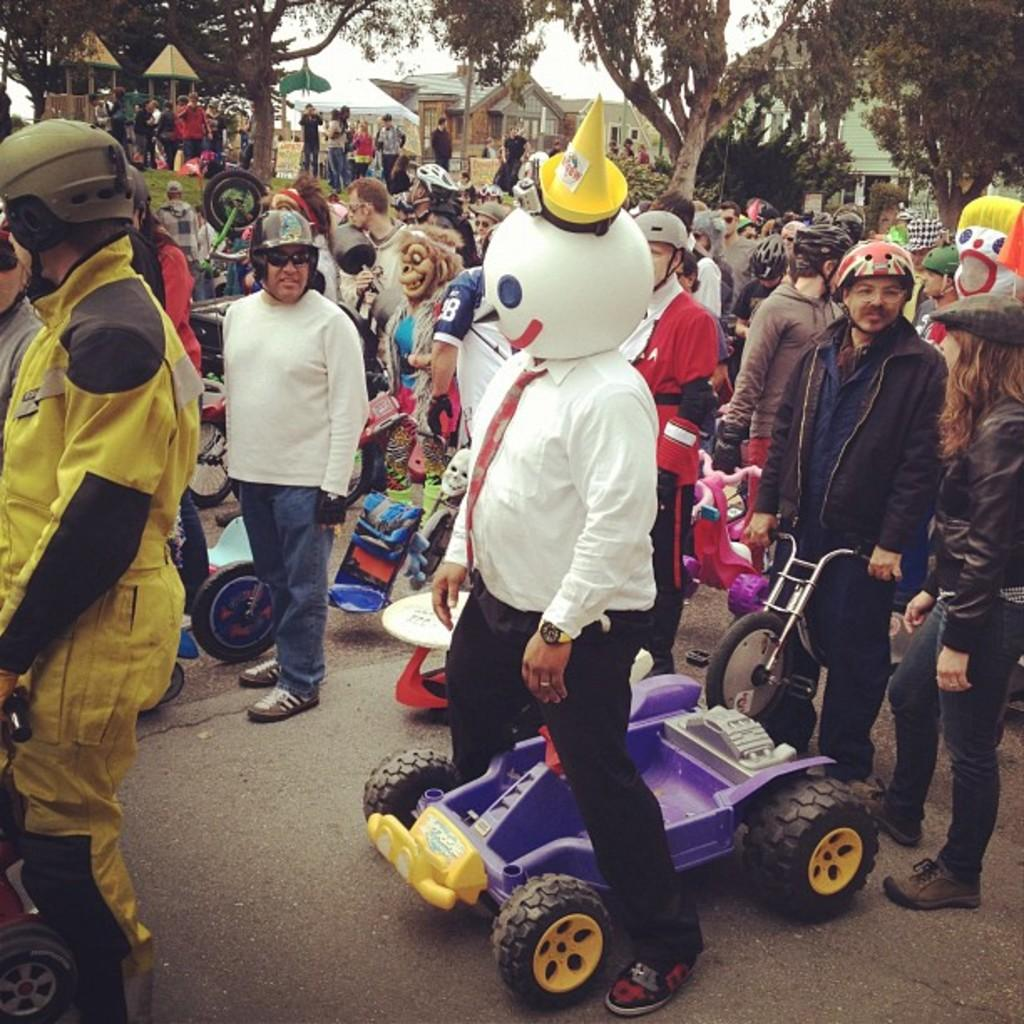What are the people in the image doing? standing in the center? What objects are at the bottom of the image? There are toy bikes at the bottom of the image. What can be seen in the background of the image? There are trees, sheds, and the sky visible in the background of the image. What type of protective gear is present in the image? Masks are present in the image. What type of watch is the sister wearing in the image? There is no mention of a sister or a watch in the image, so this question cannot be answered definitively. 